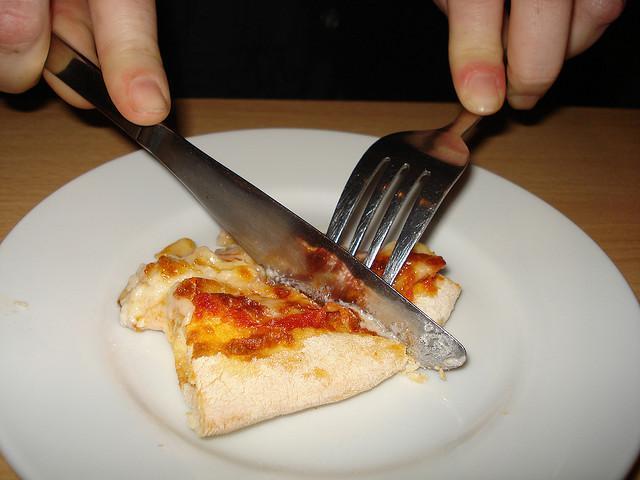How many forks are there?
Give a very brief answer. 1. How many different colors of umbrella are there?
Give a very brief answer. 0. 